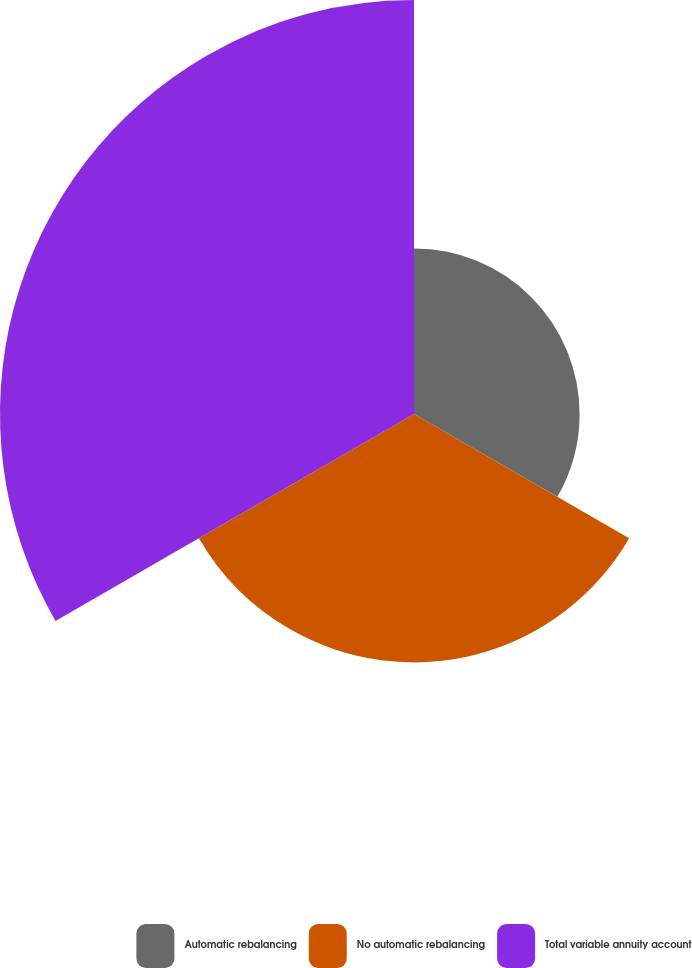Convert chart to OTSL. <chart><loc_0><loc_0><loc_500><loc_500><pie_chart><fcel>Automatic rebalancing<fcel>No automatic rebalancing<fcel>Total variable annuity account<nl><fcel>20.0%<fcel>30.0%<fcel>50.0%<nl></chart> 